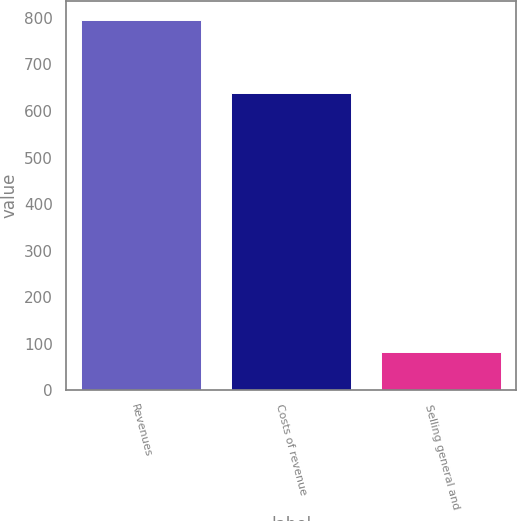Convert chart. <chart><loc_0><loc_0><loc_500><loc_500><bar_chart><fcel>Revenues<fcel>Costs of revenue<fcel>Selling general and<nl><fcel>796<fcel>639<fcel>82<nl></chart> 